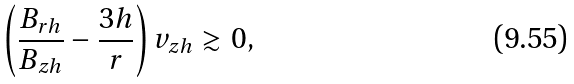Convert formula to latex. <formula><loc_0><loc_0><loc_500><loc_500>\left ( \frac { B _ { r h } } { B _ { z h } } - \frac { 3 h } { r } \right ) v _ { z h } \gtrsim 0 ,</formula> 